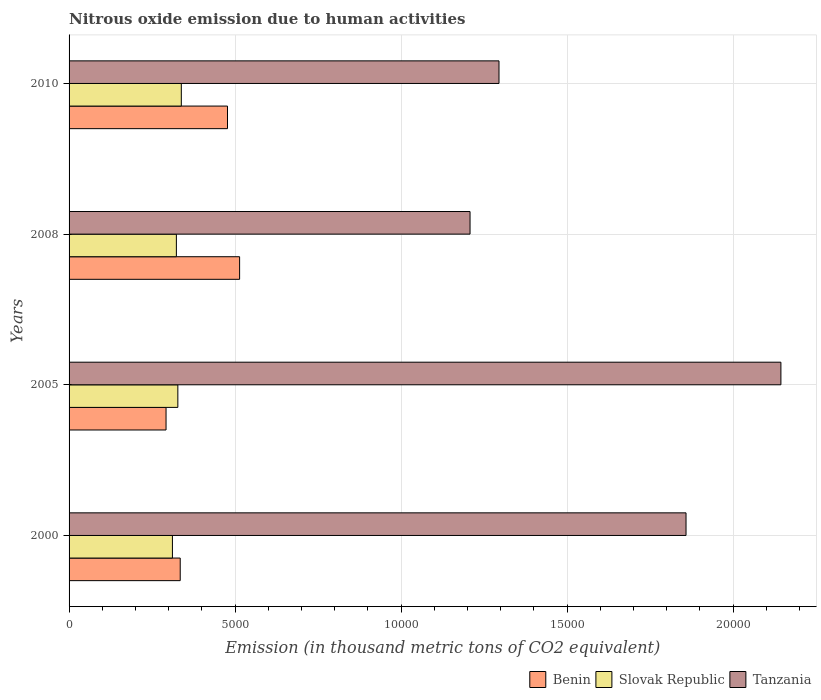How many different coloured bars are there?
Your answer should be very brief. 3. Are the number of bars per tick equal to the number of legend labels?
Provide a succinct answer. Yes. How many bars are there on the 1st tick from the top?
Make the answer very short. 3. How many bars are there on the 3rd tick from the bottom?
Your answer should be very brief. 3. What is the label of the 3rd group of bars from the top?
Ensure brevity in your answer.  2005. In how many cases, is the number of bars for a given year not equal to the number of legend labels?
Make the answer very short. 0. What is the amount of nitrous oxide emitted in Tanzania in 2000?
Offer a very short reply. 1.86e+04. Across all years, what is the maximum amount of nitrous oxide emitted in Slovak Republic?
Offer a very short reply. 3380.2. Across all years, what is the minimum amount of nitrous oxide emitted in Benin?
Offer a terse response. 2920.4. In which year was the amount of nitrous oxide emitted in Benin minimum?
Offer a terse response. 2005. What is the total amount of nitrous oxide emitted in Benin in the graph?
Offer a terse response. 1.62e+04. What is the difference between the amount of nitrous oxide emitted in Tanzania in 2000 and that in 2010?
Keep it short and to the point. 5632.7. What is the difference between the amount of nitrous oxide emitted in Benin in 2010 and the amount of nitrous oxide emitted in Tanzania in 2008?
Your answer should be compact. -7304.5. What is the average amount of nitrous oxide emitted in Benin per year?
Your answer should be compact. 4043.68. In the year 2005, what is the difference between the amount of nitrous oxide emitted in Tanzania and amount of nitrous oxide emitted in Slovak Republic?
Your response must be concise. 1.82e+04. What is the ratio of the amount of nitrous oxide emitted in Slovak Republic in 2000 to that in 2010?
Keep it short and to the point. 0.92. Is the amount of nitrous oxide emitted in Tanzania in 2005 less than that in 2008?
Give a very brief answer. No. What is the difference between the highest and the second highest amount of nitrous oxide emitted in Slovak Republic?
Your response must be concise. 104.6. What is the difference between the highest and the lowest amount of nitrous oxide emitted in Slovak Republic?
Offer a very short reply. 267.9. Is the sum of the amount of nitrous oxide emitted in Tanzania in 2005 and 2010 greater than the maximum amount of nitrous oxide emitted in Slovak Republic across all years?
Your answer should be very brief. Yes. What does the 3rd bar from the top in 2005 represents?
Your answer should be very brief. Benin. What does the 2nd bar from the bottom in 2000 represents?
Provide a short and direct response. Slovak Republic. How many bars are there?
Provide a succinct answer. 12. Are the values on the major ticks of X-axis written in scientific E-notation?
Your response must be concise. No. Does the graph contain grids?
Provide a succinct answer. Yes. What is the title of the graph?
Ensure brevity in your answer.  Nitrous oxide emission due to human activities. What is the label or title of the X-axis?
Give a very brief answer. Emission (in thousand metric tons of CO2 equivalent). What is the Emission (in thousand metric tons of CO2 equivalent) in Benin in 2000?
Keep it short and to the point. 3347.2. What is the Emission (in thousand metric tons of CO2 equivalent) of Slovak Republic in 2000?
Offer a terse response. 3112.3. What is the Emission (in thousand metric tons of CO2 equivalent) in Tanzania in 2000?
Your response must be concise. 1.86e+04. What is the Emission (in thousand metric tons of CO2 equivalent) in Benin in 2005?
Your response must be concise. 2920.4. What is the Emission (in thousand metric tons of CO2 equivalent) in Slovak Republic in 2005?
Offer a very short reply. 3275.6. What is the Emission (in thousand metric tons of CO2 equivalent) in Tanzania in 2005?
Your answer should be very brief. 2.14e+04. What is the Emission (in thousand metric tons of CO2 equivalent) of Benin in 2008?
Offer a very short reply. 5136. What is the Emission (in thousand metric tons of CO2 equivalent) of Slovak Republic in 2008?
Make the answer very short. 3231.4. What is the Emission (in thousand metric tons of CO2 equivalent) of Tanzania in 2008?
Ensure brevity in your answer.  1.21e+04. What is the Emission (in thousand metric tons of CO2 equivalent) of Benin in 2010?
Give a very brief answer. 4771.1. What is the Emission (in thousand metric tons of CO2 equivalent) of Slovak Republic in 2010?
Provide a short and direct response. 3380.2. What is the Emission (in thousand metric tons of CO2 equivalent) of Tanzania in 2010?
Your answer should be compact. 1.29e+04. Across all years, what is the maximum Emission (in thousand metric tons of CO2 equivalent) of Benin?
Offer a very short reply. 5136. Across all years, what is the maximum Emission (in thousand metric tons of CO2 equivalent) in Slovak Republic?
Give a very brief answer. 3380.2. Across all years, what is the maximum Emission (in thousand metric tons of CO2 equivalent) in Tanzania?
Give a very brief answer. 2.14e+04. Across all years, what is the minimum Emission (in thousand metric tons of CO2 equivalent) in Benin?
Keep it short and to the point. 2920.4. Across all years, what is the minimum Emission (in thousand metric tons of CO2 equivalent) of Slovak Republic?
Keep it short and to the point. 3112.3. Across all years, what is the minimum Emission (in thousand metric tons of CO2 equivalent) of Tanzania?
Offer a very short reply. 1.21e+04. What is the total Emission (in thousand metric tons of CO2 equivalent) in Benin in the graph?
Your response must be concise. 1.62e+04. What is the total Emission (in thousand metric tons of CO2 equivalent) of Slovak Republic in the graph?
Your answer should be very brief. 1.30e+04. What is the total Emission (in thousand metric tons of CO2 equivalent) of Tanzania in the graph?
Ensure brevity in your answer.  6.50e+04. What is the difference between the Emission (in thousand metric tons of CO2 equivalent) of Benin in 2000 and that in 2005?
Your answer should be compact. 426.8. What is the difference between the Emission (in thousand metric tons of CO2 equivalent) of Slovak Republic in 2000 and that in 2005?
Ensure brevity in your answer.  -163.3. What is the difference between the Emission (in thousand metric tons of CO2 equivalent) in Tanzania in 2000 and that in 2005?
Offer a very short reply. -2857.2. What is the difference between the Emission (in thousand metric tons of CO2 equivalent) in Benin in 2000 and that in 2008?
Offer a terse response. -1788.8. What is the difference between the Emission (in thousand metric tons of CO2 equivalent) in Slovak Republic in 2000 and that in 2008?
Your response must be concise. -119.1. What is the difference between the Emission (in thousand metric tons of CO2 equivalent) of Tanzania in 2000 and that in 2008?
Keep it short and to the point. 6504.6. What is the difference between the Emission (in thousand metric tons of CO2 equivalent) in Benin in 2000 and that in 2010?
Make the answer very short. -1423.9. What is the difference between the Emission (in thousand metric tons of CO2 equivalent) in Slovak Republic in 2000 and that in 2010?
Ensure brevity in your answer.  -267.9. What is the difference between the Emission (in thousand metric tons of CO2 equivalent) in Tanzania in 2000 and that in 2010?
Ensure brevity in your answer.  5632.7. What is the difference between the Emission (in thousand metric tons of CO2 equivalent) of Benin in 2005 and that in 2008?
Your answer should be very brief. -2215.6. What is the difference between the Emission (in thousand metric tons of CO2 equivalent) of Slovak Republic in 2005 and that in 2008?
Offer a terse response. 44.2. What is the difference between the Emission (in thousand metric tons of CO2 equivalent) in Tanzania in 2005 and that in 2008?
Give a very brief answer. 9361.8. What is the difference between the Emission (in thousand metric tons of CO2 equivalent) in Benin in 2005 and that in 2010?
Your answer should be compact. -1850.7. What is the difference between the Emission (in thousand metric tons of CO2 equivalent) in Slovak Republic in 2005 and that in 2010?
Provide a short and direct response. -104.6. What is the difference between the Emission (in thousand metric tons of CO2 equivalent) of Tanzania in 2005 and that in 2010?
Provide a succinct answer. 8489.9. What is the difference between the Emission (in thousand metric tons of CO2 equivalent) in Benin in 2008 and that in 2010?
Offer a very short reply. 364.9. What is the difference between the Emission (in thousand metric tons of CO2 equivalent) of Slovak Republic in 2008 and that in 2010?
Make the answer very short. -148.8. What is the difference between the Emission (in thousand metric tons of CO2 equivalent) of Tanzania in 2008 and that in 2010?
Give a very brief answer. -871.9. What is the difference between the Emission (in thousand metric tons of CO2 equivalent) of Benin in 2000 and the Emission (in thousand metric tons of CO2 equivalent) of Slovak Republic in 2005?
Your answer should be compact. 71.6. What is the difference between the Emission (in thousand metric tons of CO2 equivalent) of Benin in 2000 and the Emission (in thousand metric tons of CO2 equivalent) of Tanzania in 2005?
Your answer should be compact. -1.81e+04. What is the difference between the Emission (in thousand metric tons of CO2 equivalent) of Slovak Republic in 2000 and the Emission (in thousand metric tons of CO2 equivalent) of Tanzania in 2005?
Keep it short and to the point. -1.83e+04. What is the difference between the Emission (in thousand metric tons of CO2 equivalent) of Benin in 2000 and the Emission (in thousand metric tons of CO2 equivalent) of Slovak Republic in 2008?
Ensure brevity in your answer.  115.8. What is the difference between the Emission (in thousand metric tons of CO2 equivalent) of Benin in 2000 and the Emission (in thousand metric tons of CO2 equivalent) of Tanzania in 2008?
Give a very brief answer. -8728.4. What is the difference between the Emission (in thousand metric tons of CO2 equivalent) in Slovak Republic in 2000 and the Emission (in thousand metric tons of CO2 equivalent) in Tanzania in 2008?
Your response must be concise. -8963.3. What is the difference between the Emission (in thousand metric tons of CO2 equivalent) of Benin in 2000 and the Emission (in thousand metric tons of CO2 equivalent) of Slovak Republic in 2010?
Ensure brevity in your answer.  -33. What is the difference between the Emission (in thousand metric tons of CO2 equivalent) in Benin in 2000 and the Emission (in thousand metric tons of CO2 equivalent) in Tanzania in 2010?
Offer a very short reply. -9600.3. What is the difference between the Emission (in thousand metric tons of CO2 equivalent) in Slovak Republic in 2000 and the Emission (in thousand metric tons of CO2 equivalent) in Tanzania in 2010?
Provide a short and direct response. -9835.2. What is the difference between the Emission (in thousand metric tons of CO2 equivalent) in Benin in 2005 and the Emission (in thousand metric tons of CO2 equivalent) in Slovak Republic in 2008?
Provide a succinct answer. -311. What is the difference between the Emission (in thousand metric tons of CO2 equivalent) of Benin in 2005 and the Emission (in thousand metric tons of CO2 equivalent) of Tanzania in 2008?
Your response must be concise. -9155.2. What is the difference between the Emission (in thousand metric tons of CO2 equivalent) in Slovak Republic in 2005 and the Emission (in thousand metric tons of CO2 equivalent) in Tanzania in 2008?
Keep it short and to the point. -8800. What is the difference between the Emission (in thousand metric tons of CO2 equivalent) of Benin in 2005 and the Emission (in thousand metric tons of CO2 equivalent) of Slovak Republic in 2010?
Your answer should be compact. -459.8. What is the difference between the Emission (in thousand metric tons of CO2 equivalent) of Benin in 2005 and the Emission (in thousand metric tons of CO2 equivalent) of Tanzania in 2010?
Keep it short and to the point. -1.00e+04. What is the difference between the Emission (in thousand metric tons of CO2 equivalent) in Slovak Republic in 2005 and the Emission (in thousand metric tons of CO2 equivalent) in Tanzania in 2010?
Offer a very short reply. -9671.9. What is the difference between the Emission (in thousand metric tons of CO2 equivalent) of Benin in 2008 and the Emission (in thousand metric tons of CO2 equivalent) of Slovak Republic in 2010?
Provide a short and direct response. 1755.8. What is the difference between the Emission (in thousand metric tons of CO2 equivalent) in Benin in 2008 and the Emission (in thousand metric tons of CO2 equivalent) in Tanzania in 2010?
Keep it short and to the point. -7811.5. What is the difference between the Emission (in thousand metric tons of CO2 equivalent) in Slovak Republic in 2008 and the Emission (in thousand metric tons of CO2 equivalent) in Tanzania in 2010?
Provide a succinct answer. -9716.1. What is the average Emission (in thousand metric tons of CO2 equivalent) of Benin per year?
Your answer should be compact. 4043.68. What is the average Emission (in thousand metric tons of CO2 equivalent) in Slovak Republic per year?
Offer a terse response. 3249.88. What is the average Emission (in thousand metric tons of CO2 equivalent) of Tanzania per year?
Your answer should be compact. 1.63e+04. In the year 2000, what is the difference between the Emission (in thousand metric tons of CO2 equivalent) in Benin and Emission (in thousand metric tons of CO2 equivalent) in Slovak Republic?
Provide a succinct answer. 234.9. In the year 2000, what is the difference between the Emission (in thousand metric tons of CO2 equivalent) in Benin and Emission (in thousand metric tons of CO2 equivalent) in Tanzania?
Offer a terse response. -1.52e+04. In the year 2000, what is the difference between the Emission (in thousand metric tons of CO2 equivalent) of Slovak Republic and Emission (in thousand metric tons of CO2 equivalent) of Tanzania?
Offer a very short reply. -1.55e+04. In the year 2005, what is the difference between the Emission (in thousand metric tons of CO2 equivalent) in Benin and Emission (in thousand metric tons of CO2 equivalent) in Slovak Republic?
Your response must be concise. -355.2. In the year 2005, what is the difference between the Emission (in thousand metric tons of CO2 equivalent) of Benin and Emission (in thousand metric tons of CO2 equivalent) of Tanzania?
Your response must be concise. -1.85e+04. In the year 2005, what is the difference between the Emission (in thousand metric tons of CO2 equivalent) of Slovak Republic and Emission (in thousand metric tons of CO2 equivalent) of Tanzania?
Ensure brevity in your answer.  -1.82e+04. In the year 2008, what is the difference between the Emission (in thousand metric tons of CO2 equivalent) of Benin and Emission (in thousand metric tons of CO2 equivalent) of Slovak Republic?
Make the answer very short. 1904.6. In the year 2008, what is the difference between the Emission (in thousand metric tons of CO2 equivalent) of Benin and Emission (in thousand metric tons of CO2 equivalent) of Tanzania?
Make the answer very short. -6939.6. In the year 2008, what is the difference between the Emission (in thousand metric tons of CO2 equivalent) of Slovak Republic and Emission (in thousand metric tons of CO2 equivalent) of Tanzania?
Offer a terse response. -8844.2. In the year 2010, what is the difference between the Emission (in thousand metric tons of CO2 equivalent) in Benin and Emission (in thousand metric tons of CO2 equivalent) in Slovak Republic?
Your response must be concise. 1390.9. In the year 2010, what is the difference between the Emission (in thousand metric tons of CO2 equivalent) in Benin and Emission (in thousand metric tons of CO2 equivalent) in Tanzania?
Give a very brief answer. -8176.4. In the year 2010, what is the difference between the Emission (in thousand metric tons of CO2 equivalent) of Slovak Republic and Emission (in thousand metric tons of CO2 equivalent) of Tanzania?
Make the answer very short. -9567.3. What is the ratio of the Emission (in thousand metric tons of CO2 equivalent) of Benin in 2000 to that in 2005?
Your answer should be compact. 1.15. What is the ratio of the Emission (in thousand metric tons of CO2 equivalent) in Slovak Republic in 2000 to that in 2005?
Your response must be concise. 0.95. What is the ratio of the Emission (in thousand metric tons of CO2 equivalent) in Tanzania in 2000 to that in 2005?
Your answer should be compact. 0.87. What is the ratio of the Emission (in thousand metric tons of CO2 equivalent) of Benin in 2000 to that in 2008?
Give a very brief answer. 0.65. What is the ratio of the Emission (in thousand metric tons of CO2 equivalent) in Slovak Republic in 2000 to that in 2008?
Make the answer very short. 0.96. What is the ratio of the Emission (in thousand metric tons of CO2 equivalent) of Tanzania in 2000 to that in 2008?
Your answer should be compact. 1.54. What is the ratio of the Emission (in thousand metric tons of CO2 equivalent) of Benin in 2000 to that in 2010?
Keep it short and to the point. 0.7. What is the ratio of the Emission (in thousand metric tons of CO2 equivalent) in Slovak Republic in 2000 to that in 2010?
Make the answer very short. 0.92. What is the ratio of the Emission (in thousand metric tons of CO2 equivalent) in Tanzania in 2000 to that in 2010?
Your answer should be compact. 1.44. What is the ratio of the Emission (in thousand metric tons of CO2 equivalent) of Benin in 2005 to that in 2008?
Your answer should be compact. 0.57. What is the ratio of the Emission (in thousand metric tons of CO2 equivalent) in Slovak Republic in 2005 to that in 2008?
Keep it short and to the point. 1.01. What is the ratio of the Emission (in thousand metric tons of CO2 equivalent) of Tanzania in 2005 to that in 2008?
Ensure brevity in your answer.  1.78. What is the ratio of the Emission (in thousand metric tons of CO2 equivalent) of Benin in 2005 to that in 2010?
Offer a terse response. 0.61. What is the ratio of the Emission (in thousand metric tons of CO2 equivalent) in Slovak Republic in 2005 to that in 2010?
Provide a succinct answer. 0.97. What is the ratio of the Emission (in thousand metric tons of CO2 equivalent) of Tanzania in 2005 to that in 2010?
Provide a short and direct response. 1.66. What is the ratio of the Emission (in thousand metric tons of CO2 equivalent) of Benin in 2008 to that in 2010?
Provide a succinct answer. 1.08. What is the ratio of the Emission (in thousand metric tons of CO2 equivalent) in Slovak Republic in 2008 to that in 2010?
Give a very brief answer. 0.96. What is the ratio of the Emission (in thousand metric tons of CO2 equivalent) of Tanzania in 2008 to that in 2010?
Provide a short and direct response. 0.93. What is the difference between the highest and the second highest Emission (in thousand metric tons of CO2 equivalent) in Benin?
Offer a very short reply. 364.9. What is the difference between the highest and the second highest Emission (in thousand metric tons of CO2 equivalent) in Slovak Republic?
Offer a very short reply. 104.6. What is the difference between the highest and the second highest Emission (in thousand metric tons of CO2 equivalent) of Tanzania?
Offer a very short reply. 2857.2. What is the difference between the highest and the lowest Emission (in thousand metric tons of CO2 equivalent) in Benin?
Your answer should be compact. 2215.6. What is the difference between the highest and the lowest Emission (in thousand metric tons of CO2 equivalent) in Slovak Republic?
Offer a terse response. 267.9. What is the difference between the highest and the lowest Emission (in thousand metric tons of CO2 equivalent) of Tanzania?
Ensure brevity in your answer.  9361.8. 